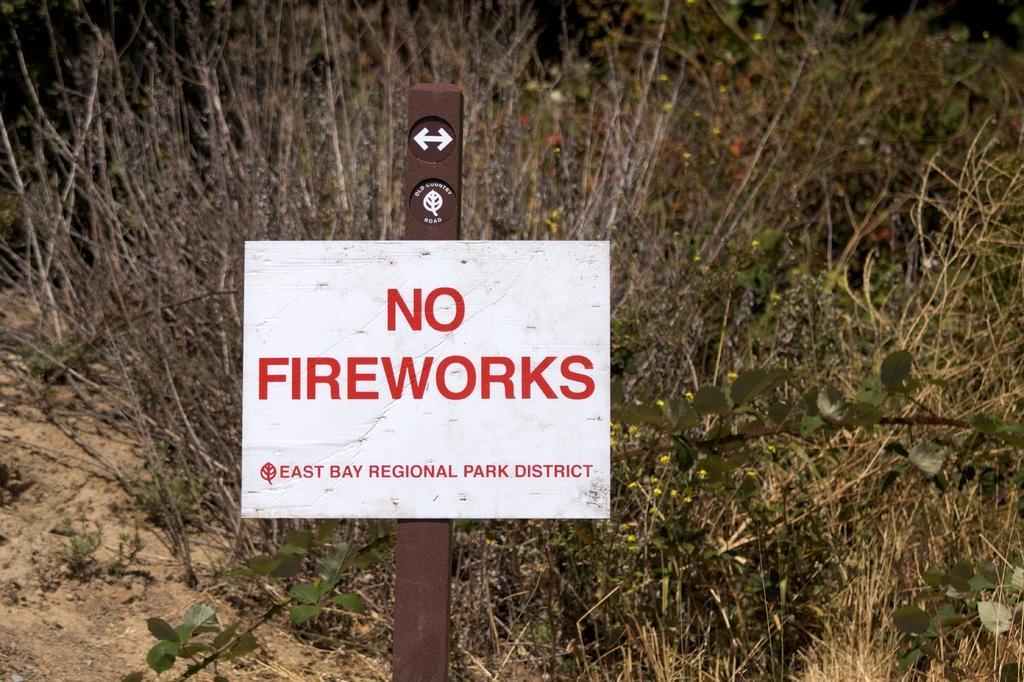In one or two sentences, can you explain what this image depicts? In this picture I can see the sign board. In the back I can see the plants and grass. In that sign board I can read that no fireworks. 